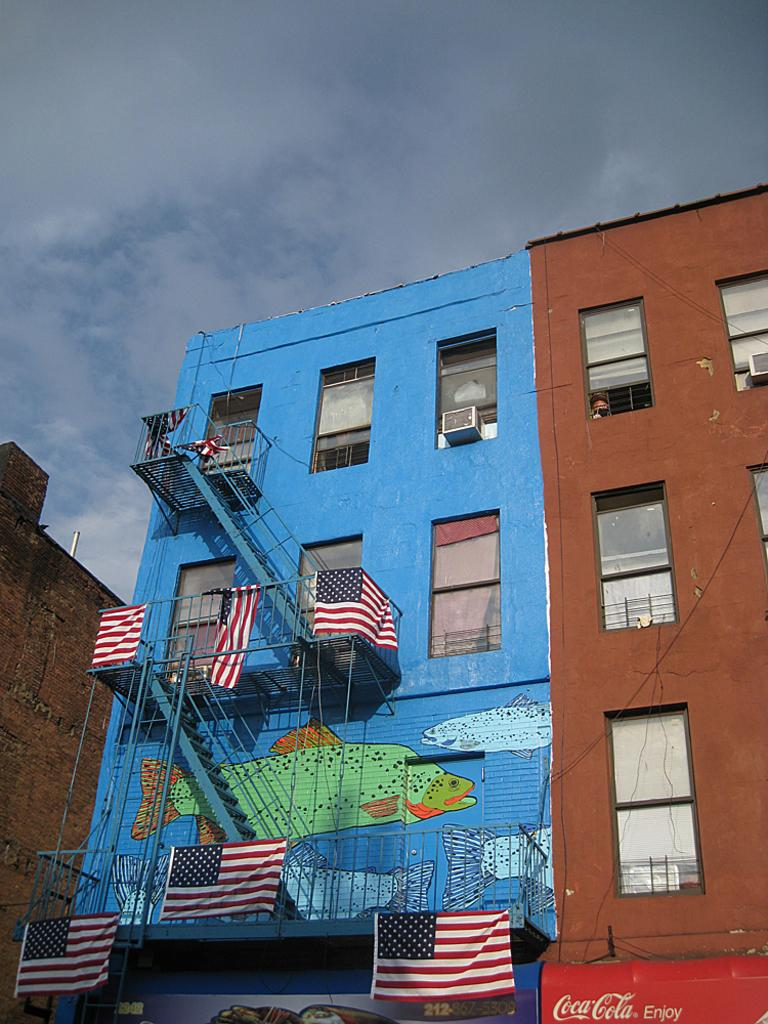What type of structures are visible in the image? There are buildings with windows in the image. What kind of artwork can be seen on a wall in the image? There is a wall painting on a wall in the image. What are the flags used for in the image? The flags are hanging in the image, possibly for decoration or to represent a specific organization or country. What architectural feature is visible in the image? There are stairs visible in the image. What can be seen in the sky in the image? There are clouds in the sky in the image. What verse is being recited by the clouds in the image? There is no verse being recited by the clouds in the image; they are simply clouds in the sky. What type of detail can be seen on the wall painting in the image? The provided facts do not mention any specific details on the wall painting, so we cannot answer this question definitively. 